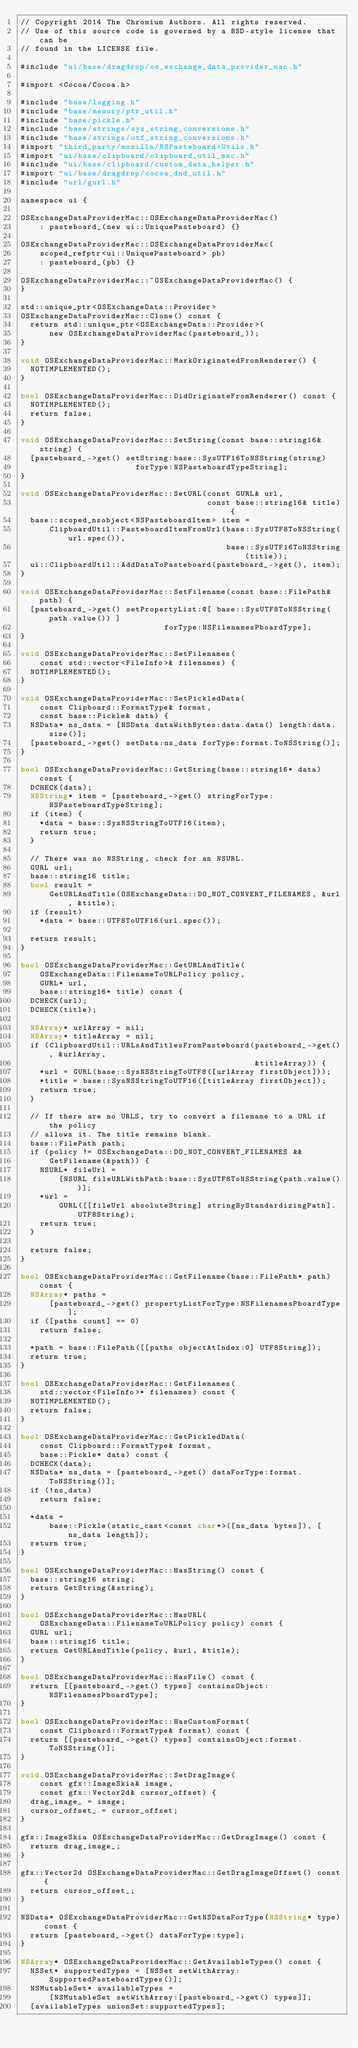Convert code to text. <code><loc_0><loc_0><loc_500><loc_500><_ObjectiveC_>// Copyright 2014 The Chromium Authors. All rights reserved.
// Use of this source code is governed by a BSD-style license that can be
// found in the LICENSE file.

#include "ui/base/dragdrop/os_exchange_data_provider_mac.h"

#import <Cocoa/Cocoa.h>

#include "base/logging.h"
#include "base/memory/ptr_util.h"
#include "base/pickle.h"
#include "base/strings/sys_string_conversions.h"
#include "base/strings/utf_string_conversions.h"
#import "third_party/mozilla/NSPasteboard+Utils.h"
#import "ui/base/clipboard/clipboard_util_mac.h"
#include "ui/base/clipboard/custom_data_helper.h"
#import "ui/base/dragdrop/cocoa_dnd_util.h"
#include "url/gurl.h"

namespace ui {

OSExchangeDataProviderMac::OSExchangeDataProviderMac()
    : pasteboard_(new ui::UniquePasteboard) {}

OSExchangeDataProviderMac::OSExchangeDataProviderMac(
    scoped_refptr<ui::UniquePasteboard> pb)
    : pasteboard_(pb) {}

OSExchangeDataProviderMac::~OSExchangeDataProviderMac() {
}

std::unique_ptr<OSExchangeData::Provider>
OSExchangeDataProviderMac::Clone() const {
  return std::unique_ptr<OSExchangeData::Provider>(
      new OSExchangeDataProviderMac(pasteboard_));
}

void OSExchangeDataProviderMac::MarkOriginatedFromRenderer() {
  NOTIMPLEMENTED();
}

bool OSExchangeDataProviderMac::DidOriginateFromRenderer() const {
  NOTIMPLEMENTED();
  return false;
}

void OSExchangeDataProviderMac::SetString(const base::string16& string) {
  [pasteboard_->get() setString:base::SysUTF16ToNSString(string)
                        forType:NSPasteboardTypeString];
}

void OSExchangeDataProviderMac::SetURL(const GURL& url,
                                       const base::string16& title) {
  base::scoped_nsobject<NSPasteboardItem> item =
      ClipboardUtil::PasteboardItemFromUrl(base::SysUTF8ToNSString(url.spec()),
                                           base::SysUTF16ToNSString(title));
  ui::ClipboardUtil::AddDataToPasteboard(pasteboard_->get(), item);
}

void OSExchangeDataProviderMac::SetFilename(const base::FilePath& path) {
  [pasteboard_->get() setPropertyList:@[ base::SysUTF8ToNSString(path.value()) ]
                              forType:NSFilenamesPboardType];
}

void OSExchangeDataProviderMac::SetFilenames(
    const std::vector<FileInfo>& filenames) {
  NOTIMPLEMENTED();
}

void OSExchangeDataProviderMac::SetPickledData(
    const Clipboard::FormatType& format,
    const base::Pickle& data) {
  NSData* ns_data = [NSData dataWithBytes:data.data() length:data.size()];
  [pasteboard_->get() setData:ns_data forType:format.ToNSString()];
}

bool OSExchangeDataProviderMac::GetString(base::string16* data) const {
  DCHECK(data);
  NSString* item = [pasteboard_->get() stringForType:NSPasteboardTypeString];
  if (item) {
    *data = base::SysNSStringToUTF16(item);
    return true;
  }

  // There was no NSString, check for an NSURL.
  GURL url;
  base::string16 title;
  bool result =
      GetURLAndTitle(OSExchangeData::DO_NOT_CONVERT_FILENAMES, &url, &title);
  if (result)
    *data = base::UTF8ToUTF16(url.spec());

  return result;
}

bool OSExchangeDataProviderMac::GetURLAndTitle(
    OSExchangeData::FilenameToURLPolicy policy,
    GURL* url,
    base::string16* title) const {
  DCHECK(url);
  DCHECK(title);

  NSArray* urlArray = nil;
  NSArray* titleArray = nil;
  if (ClipboardUtil::URLsAndTitlesFromPasteboard(pasteboard_->get(), &urlArray,
                                                 &titleArray)) {
    *url = GURL(base::SysNSStringToUTF8([urlArray firstObject]));
    *title = base::SysNSStringToUTF16([titleArray firstObject]);
    return true;
  }

  // If there are no URLS, try to convert a filename to a URL if the policy
  // allows it. The title remains blank.
  base::FilePath path;
  if (policy != OSExchangeData::DO_NOT_CONVERT_FILENAMES &&
      GetFilename(&path)) {
    NSURL* fileUrl =
        [NSURL fileURLWithPath:base::SysUTF8ToNSString(path.value())];
    *url =
        GURL([[fileUrl absoluteString] stringByStandardizingPath].UTF8String);
    return true;
  }

  return false;
}

bool OSExchangeDataProviderMac::GetFilename(base::FilePath* path) const {
  NSArray* paths =
      [pasteboard_->get() propertyListForType:NSFilenamesPboardType];
  if ([paths count] == 0)
    return false;

  *path = base::FilePath([[paths objectAtIndex:0] UTF8String]);
  return true;
}

bool OSExchangeDataProviderMac::GetFilenames(
    std::vector<FileInfo>* filenames) const {
  NOTIMPLEMENTED();
  return false;
}

bool OSExchangeDataProviderMac::GetPickledData(
    const Clipboard::FormatType& format,
    base::Pickle* data) const {
  DCHECK(data);
  NSData* ns_data = [pasteboard_->get() dataForType:format.ToNSString()];
  if (!ns_data)
    return false;

  *data =
      base::Pickle(static_cast<const char*>([ns_data bytes]), [ns_data length]);
  return true;
}

bool OSExchangeDataProviderMac::HasString() const {
  base::string16 string;
  return GetString(&string);
}

bool OSExchangeDataProviderMac::HasURL(
    OSExchangeData::FilenameToURLPolicy policy) const {
  GURL url;
  base::string16 title;
  return GetURLAndTitle(policy, &url, &title);
}

bool OSExchangeDataProviderMac::HasFile() const {
  return [[pasteboard_->get() types] containsObject:NSFilenamesPboardType];
}

bool OSExchangeDataProviderMac::HasCustomFormat(
    const Clipboard::FormatType& format) const {
  return [[pasteboard_->get() types] containsObject:format.ToNSString()];
}

void OSExchangeDataProviderMac::SetDragImage(
    const gfx::ImageSkia& image,
    const gfx::Vector2d& cursor_offset) {
  drag_image_ = image;
  cursor_offset_ = cursor_offset;
}

gfx::ImageSkia OSExchangeDataProviderMac::GetDragImage() const {
  return drag_image_;
}

gfx::Vector2d OSExchangeDataProviderMac::GetDragImageOffset() const {
  return cursor_offset_;
}

NSData* OSExchangeDataProviderMac::GetNSDataForType(NSString* type) const {
  return [pasteboard_->get() dataForType:type];
}

NSArray* OSExchangeDataProviderMac::GetAvailableTypes() const {
  NSSet* supportedTypes = [NSSet setWithArray:SupportedPasteboardTypes()];
  NSMutableSet* availableTypes =
      [NSMutableSet setWithArray:[pasteboard_->get() types]];
  [availableTypes unionSet:supportedTypes];</code> 